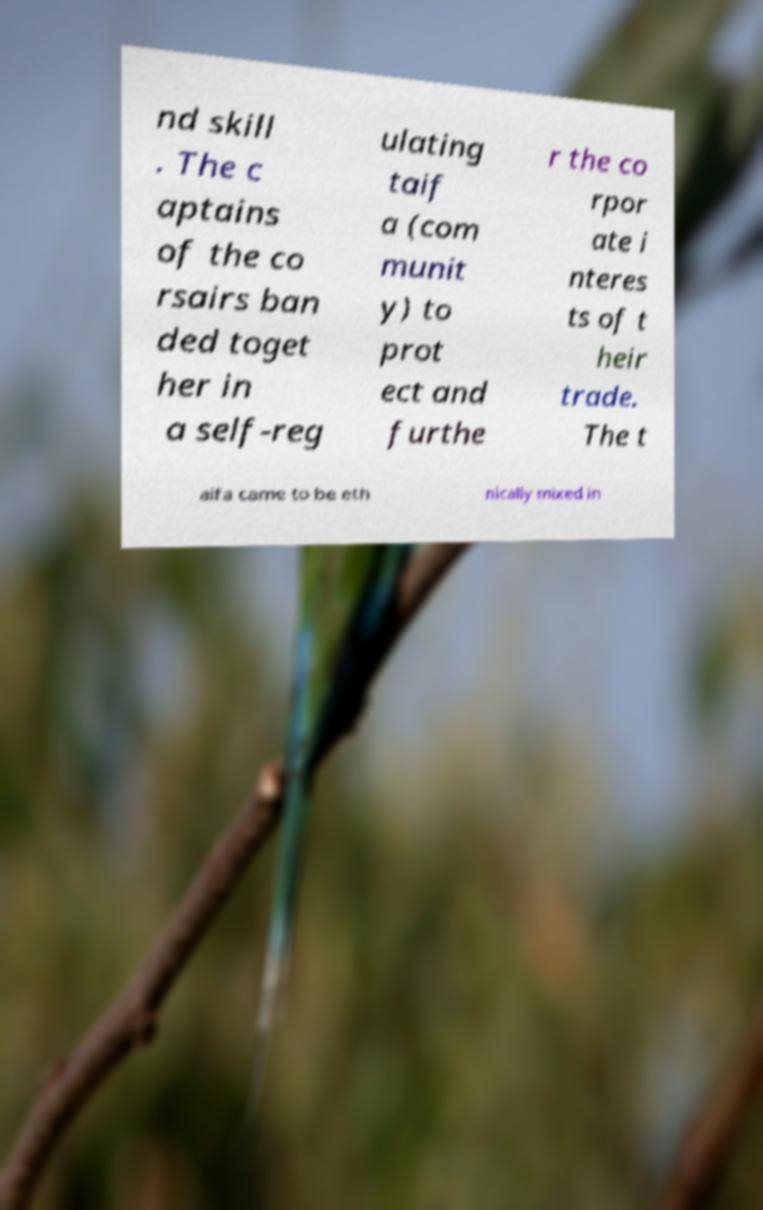Please identify and transcribe the text found in this image. nd skill . The c aptains of the co rsairs ban ded toget her in a self-reg ulating taif a (com munit y) to prot ect and furthe r the co rpor ate i nteres ts of t heir trade. The t aifa came to be eth nically mixed in 